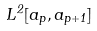Convert formula to latex. <formula><loc_0><loc_0><loc_500><loc_500>L ^ { 2 } [ a _ { p } , a _ { p + 1 } ]</formula> 